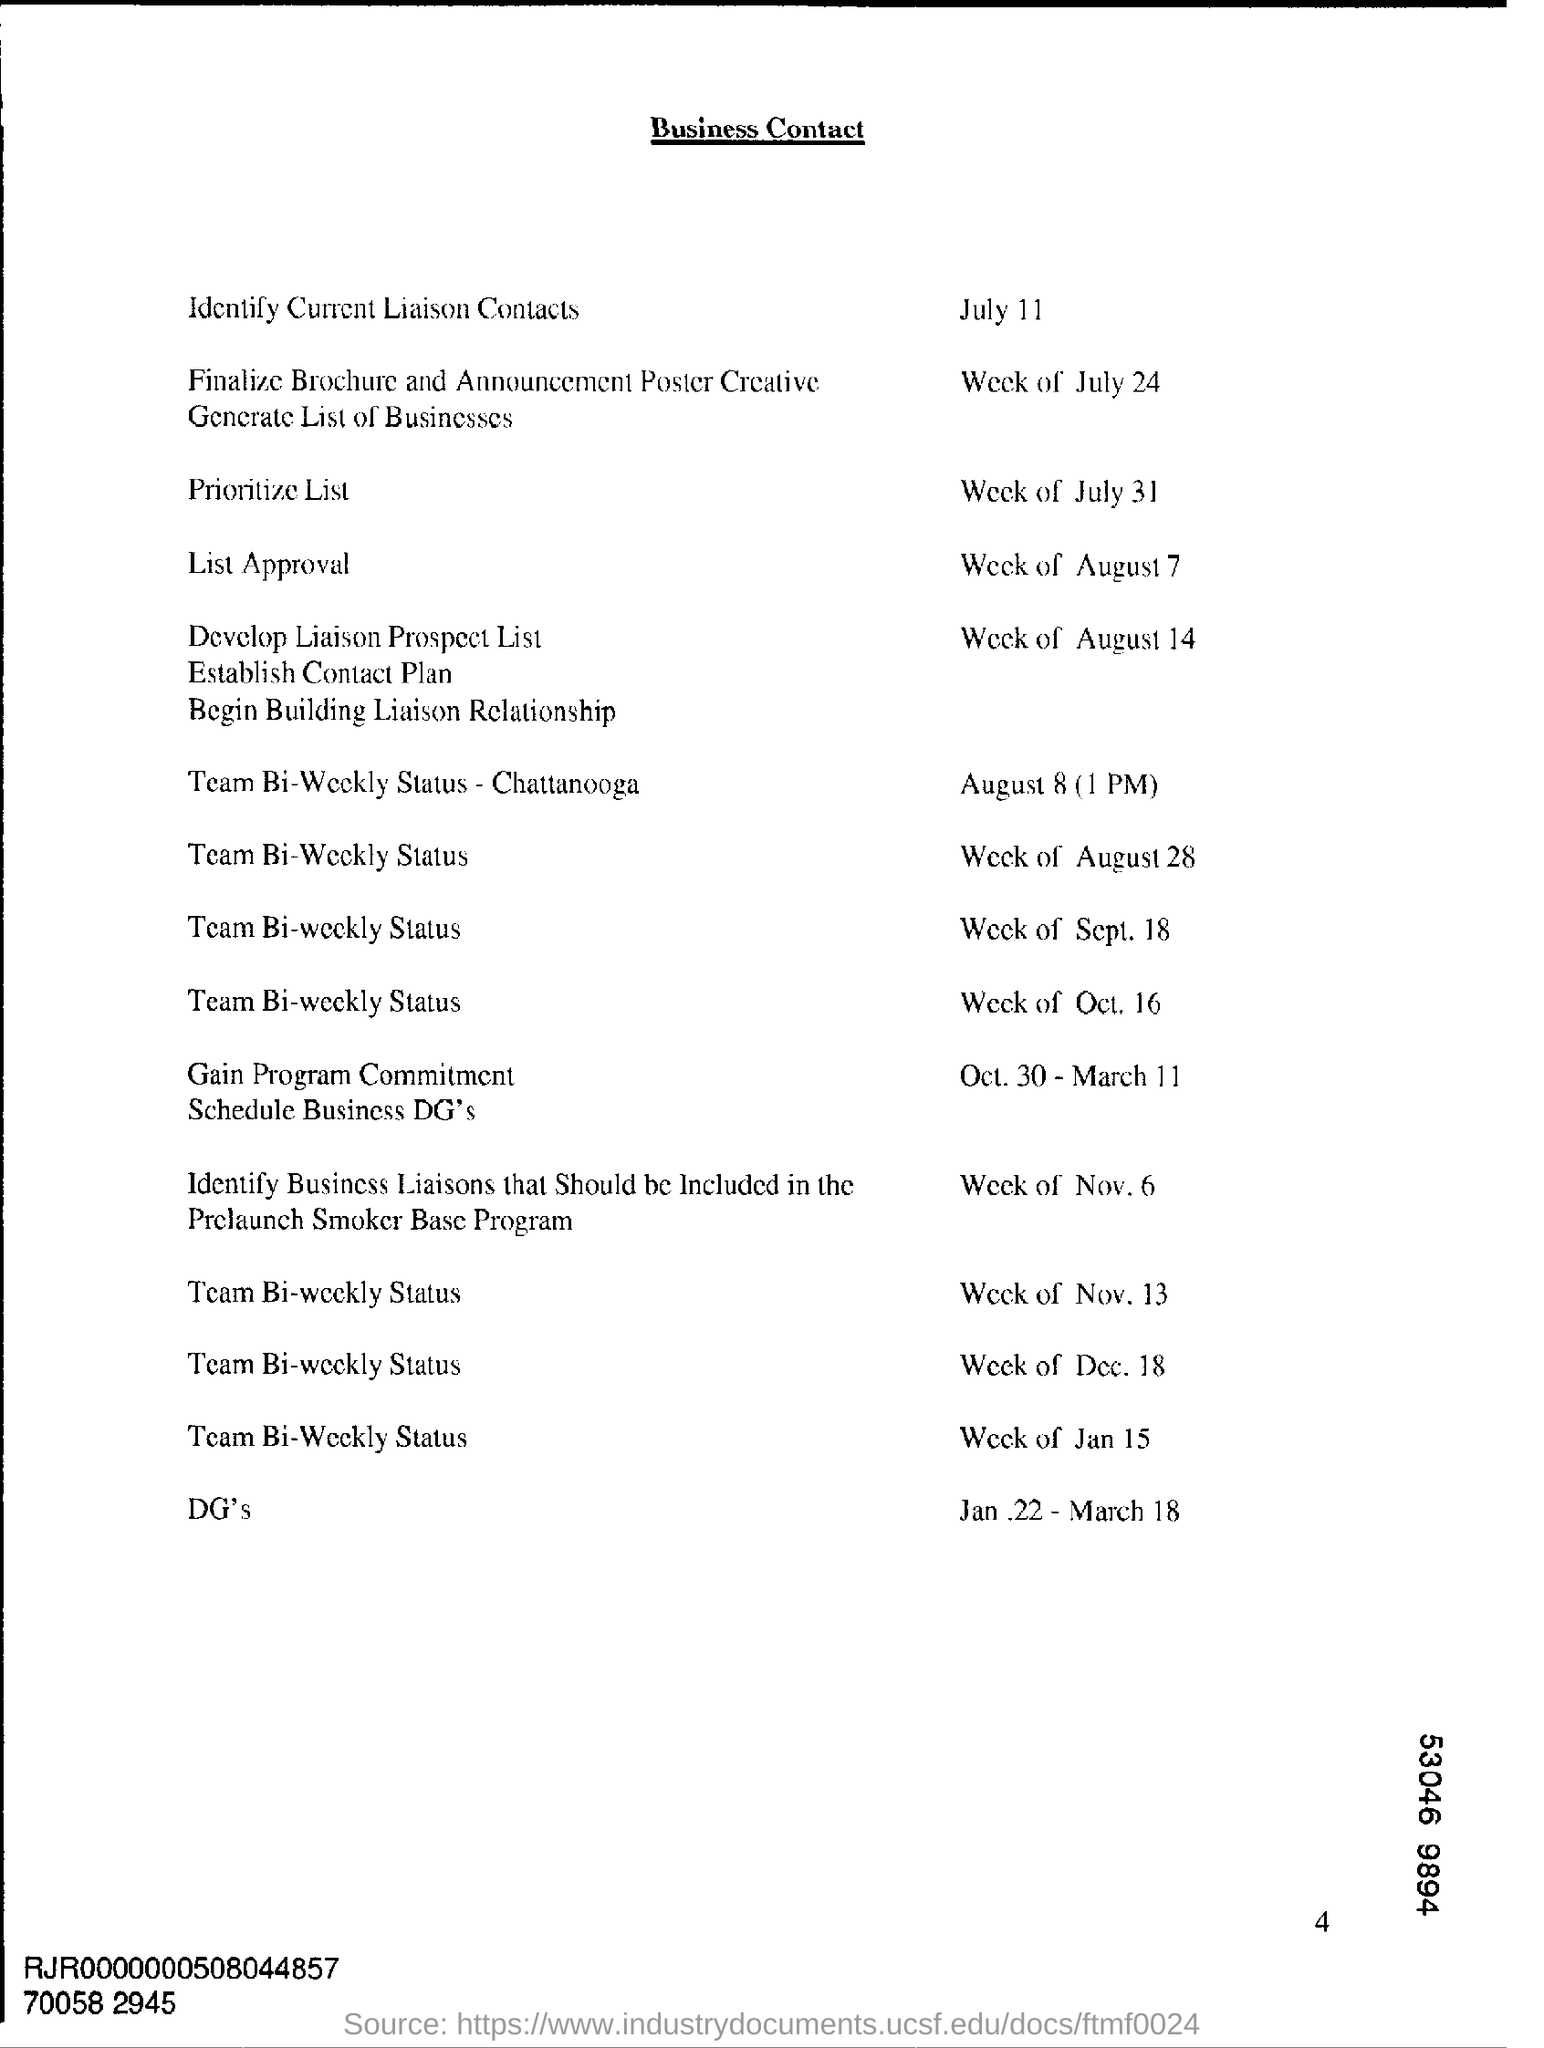What is the heading of the document?
Provide a short and direct response. Business Contact. 